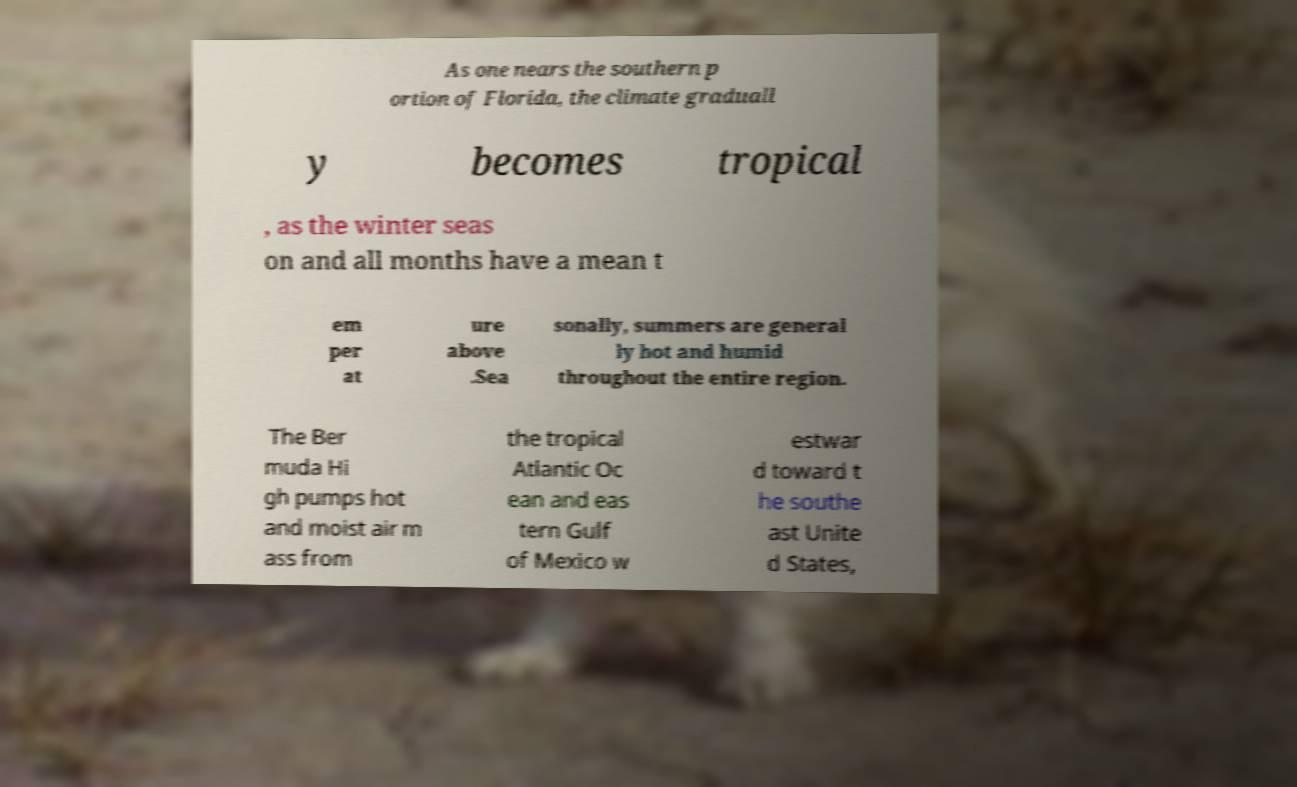Can you accurately transcribe the text from the provided image for me? As one nears the southern p ortion of Florida, the climate graduall y becomes tropical , as the winter seas on and all months have a mean t em per at ure above .Sea sonally, summers are general ly hot and humid throughout the entire region. The Ber muda Hi gh pumps hot and moist air m ass from the tropical Atlantic Oc ean and eas tern Gulf of Mexico w estwar d toward t he southe ast Unite d States, 